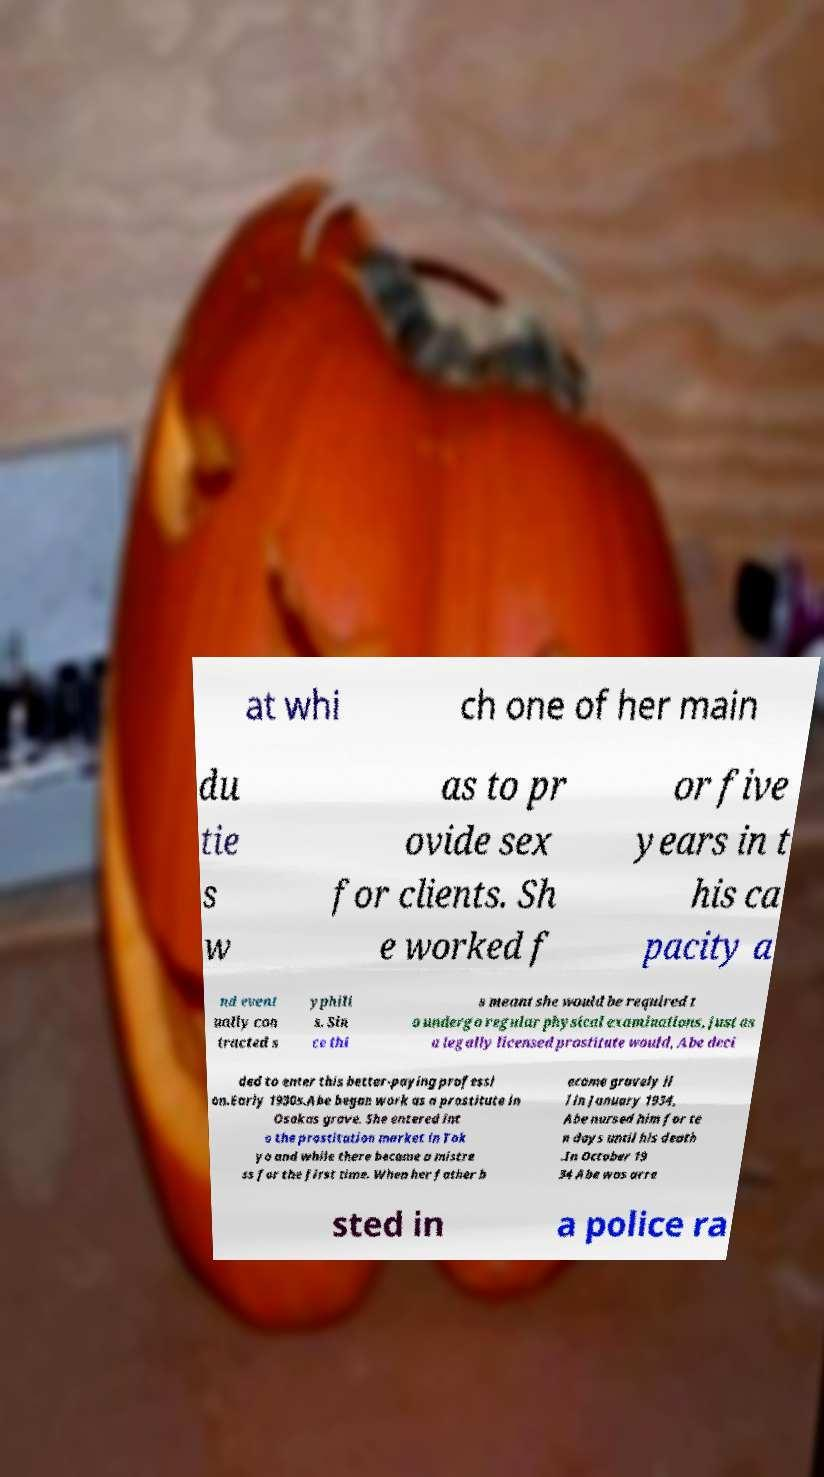There's text embedded in this image that I need extracted. Can you transcribe it verbatim? at whi ch one of her main du tie s w as to pr ovide sex for clients. Sh e worked f or five years in t his ca pacity a nd event ually con tracted s yphili s. Sin ce thi s meant she would be required t o undergo regular physical examinations, just as a legally licensed prostitute would, Abe deci ded to enter this better-paying professi on.Early 1930s.Abe began work as a prostitute in Osakas grave. She entered int o the prostitution market in Tok yo and while there became a mistre ss for the first time. When her father b ecame gravely il l in January 1934, Abe nursed him for te n days until his death .In October 19 34 Abe was arre sted in a police ra 